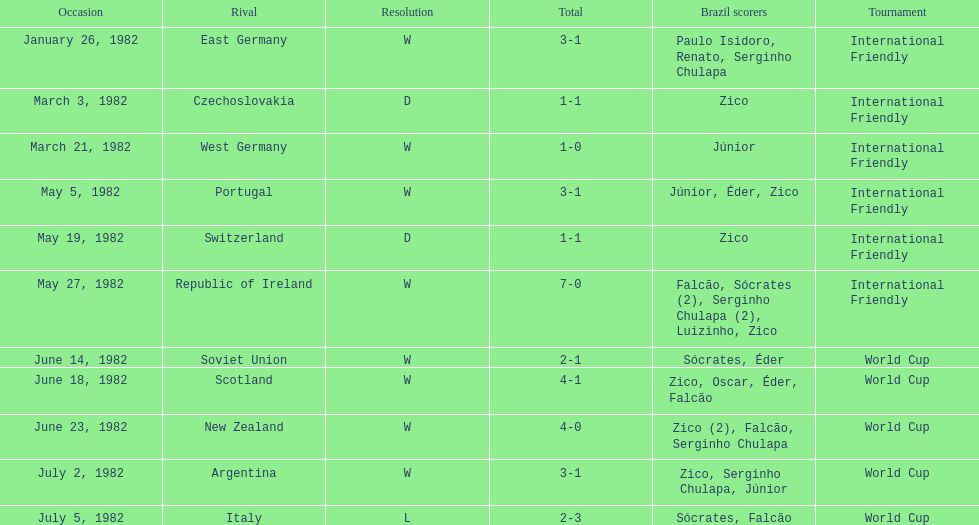During the 1982 season, how many encounters took place between brazil and west germany? 1. 